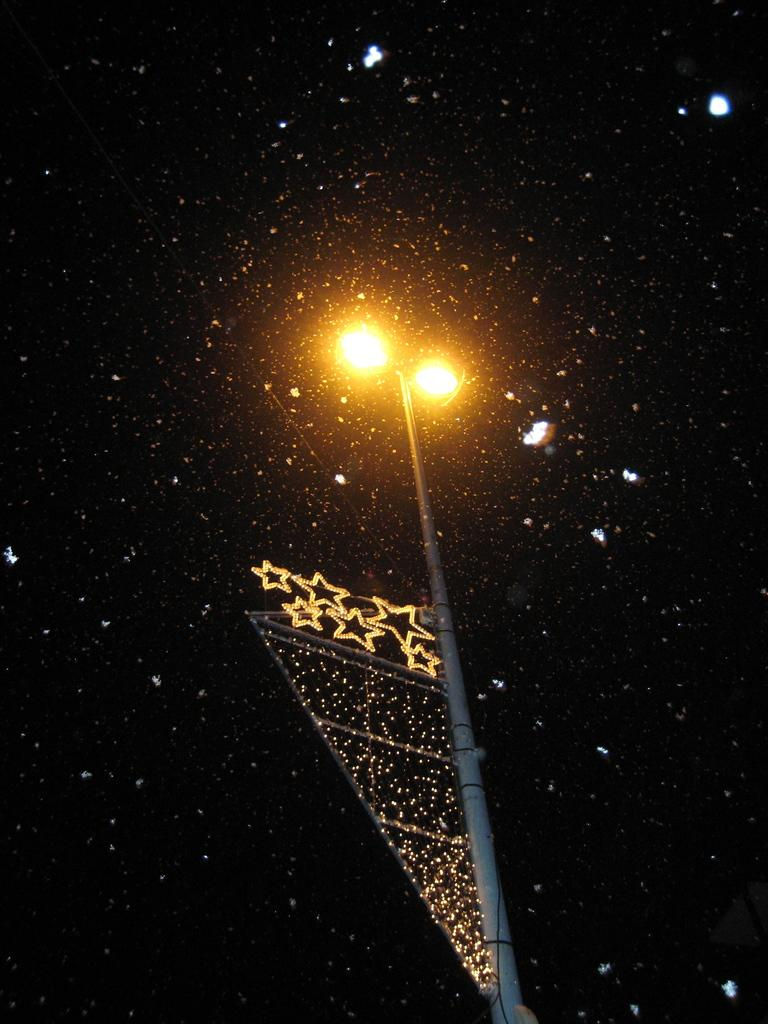What is happening in the image? Snow is falling in the image. What structure can be seen in the image? There is a light pole in the image. What decorative feature is on the light pole? Star lights are present on the light pole. What is the color of the sky in the background of the image? The sky is dark in the background of the image. Where is the mailbox located in the image? There is no mailbox present in the image. What type of journey is depicted in the image? The image does not depict a journey; it shows snow falling and a light pole with star lights. 